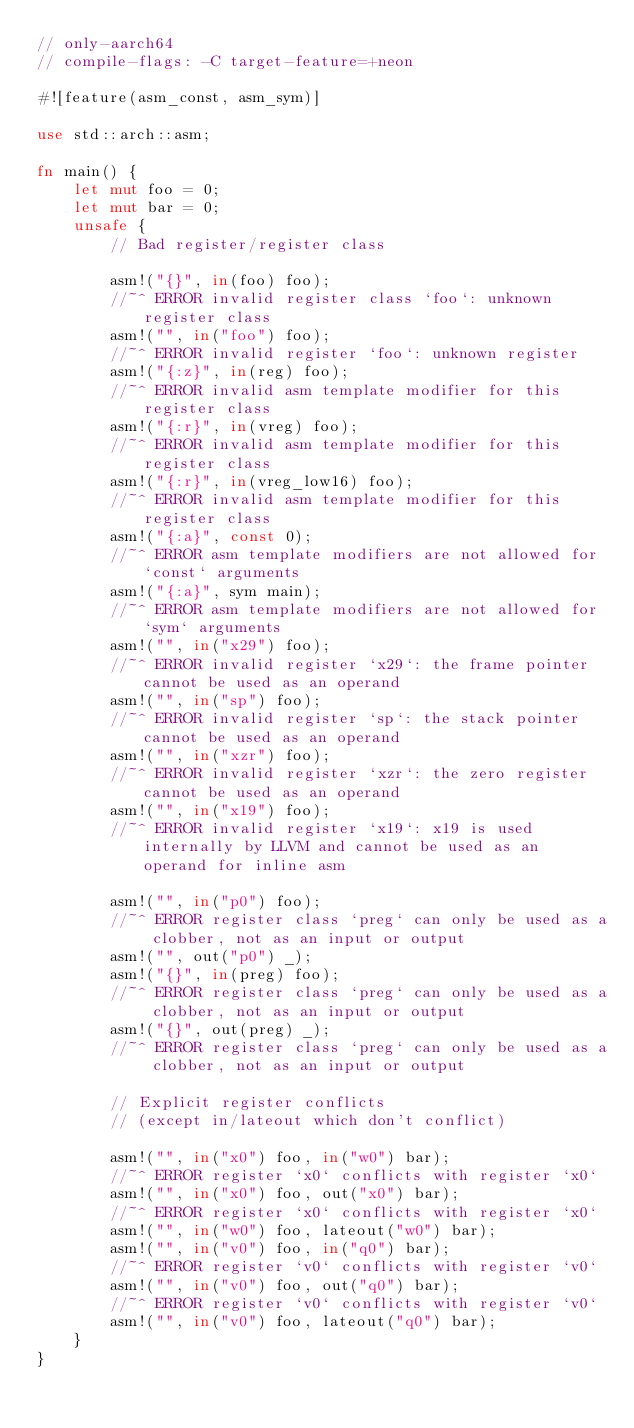<code> <loc_0><loc_0><loc_500><loc_500><_Rust_>// only-aarch64
// compile-flags: -C target-feature=+neon

#![feature(asm_const, asm_sym)]

use std::arch::asm;

fn main() {
    let mut foo = 0;
    let mut bar = 0;
    unsafe {
        // Bad register/register class

        asm!("{}", in(foo) foo);
        //~^ ERROR invalid register class `foo`: unknown register class
        asm!("", in("foo") foo);
        //~^ ERROR invalid register `foo`: unknown register
        asm!("{:z}", in(reg) foo);
        //~^ ERROR invalid asm template modifier for this register class
        asm!("{:r}", in(vreg) foo);
        //~^ ERROR invalid asm template modifier for this register class
        asm!("{:r}", in(vreg_low16) foo);
        //~^ ERROR invalid asm template modifier for this register class
        asm!("{:a}", const 0);
        //~^ ERROR asm template modifiers are not allowed for `const` arguments
        asm!("{:a}", sym main);
        //~^ ERROR asm template modifiers are not allowed for `sym` arguments
        asm!("", in("x29") foo);
        //~^ ERROR invalid register `x29`: the frame pointer cannot be used as an operand
        asm!("", in("sp") foo);
        //~^ ERROR invalid register `sp`: the stack pointer cannot be used as an operand
        asm!("", in("xzr") foo);
        //~^ ERROR invalid register `xzr`: the zero register cannot be used as an operand
        asm!("", in("x19") foo);
        //~^ ERROR invalid register `x19`: x19 is used internally by LLVM and cannot be used as an operand for inline asm

        asm!("", in("p0") foo);
        //~^ ERROR register class `preg` can only be used as a clobber, not as an input or output
        asm!("", out("p0") _);
        asm!("{}", in(preg) foo);
        //~^ ERROR register class `preg` can only be used as a clobber, not as an input or output
        asm!("{}", out(preg) _);
        //~^ ERROR register class `preg` can only be used as a clobber, not as an input or output

        // Explicit register conflicts
        // (except in/lateout which don't conflict)

        asm!("", in("x0") foo, in("w0") bar);
        //~^ ERROR register `x0` conflicts with register `x0`
        asm!("", in("x0") foo, out("x0") bar);
        //~^ ERROR register `x0` conflicts with register `x0`
        asm!("", in("w0") foo, lateout("w0") bar);
        asm!("", in("v0") foo, in("q0") bar);
        //~^ ERROR register `v0` conflicts with register `v0`
        asm!("", in("v0") foo, out("q0") bar);
        //~^ ERROR register `v0` conflicts with register `v0`
        asm!("", in("v0") foo, lateout("q0") bar);
    }
}
</code> 